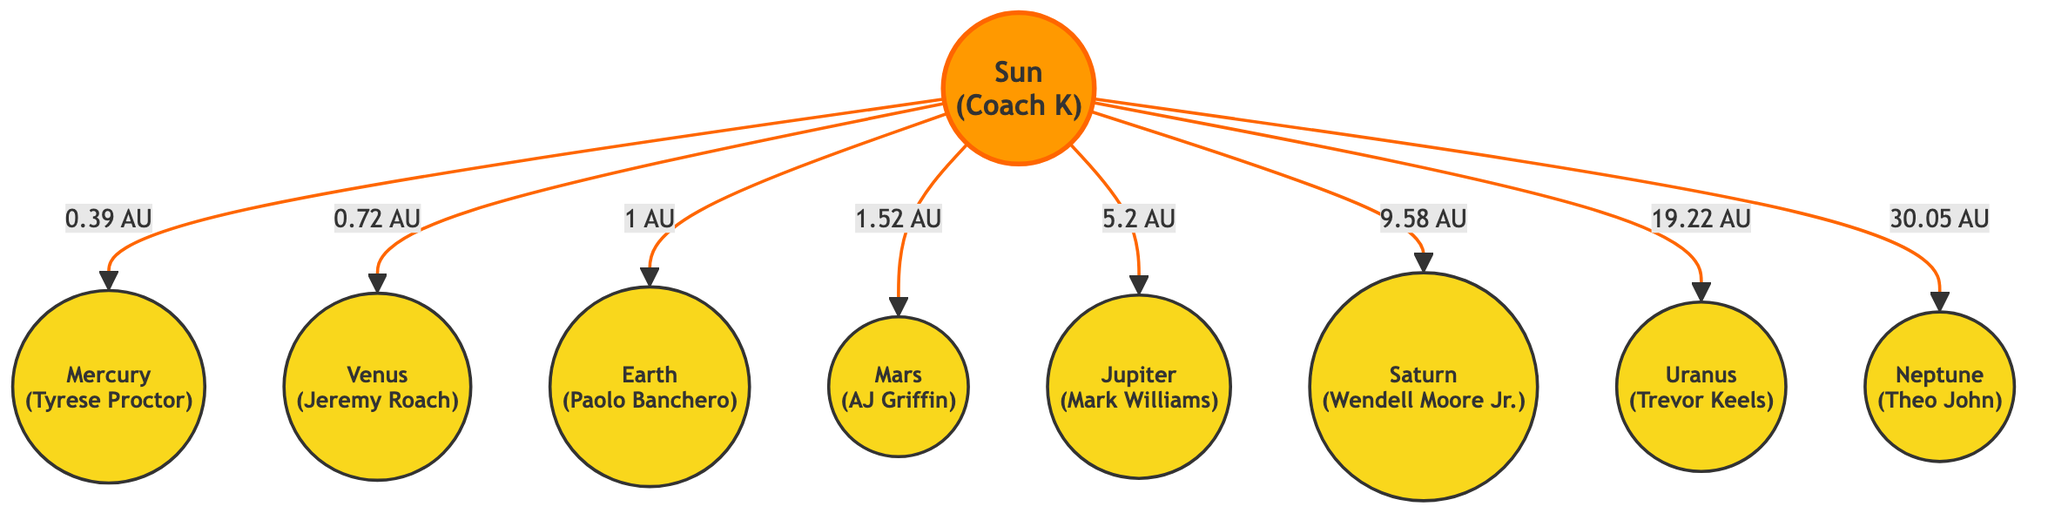What is the distance from the Sun to Mars? The Sun is connected to Mars by a link labeled "1.52 AU". This indicates that the distance from the Sun to Mars is 1.52 astronomical units.
Answer: 1.52 AU Who is represented by Jupiter? Jupiter is represented in the diagram by the label "Jupiter<br/>(Mark Williams)", which indicates that Mark Williams is the player associated with the planet Jupiter.
Answer: Mark Williams Which planet is closest to the Sun? Mercury is directly connected to the Sun with the shortest distance labeled "0.39 AU", making it the closest planet to the Sun.
Answer: Mercury How many planets are represented in this diagram? The diagram clearly shows eight planetary nodes connected to the Sun, which can be counted as each node is distinct and labeled. Thus, the total number of planets is eight.
Answer: Eight Which player corresponds to Neptune? The label next to Neptune reads "Neptune<br/>(Theo John)", indicating that Theo John represents the planet Neptune.
Answer: Theo John What is the distance from the Sun to Saturn? The link from the Sun to Saturn is labeled "9.58 AU", meaning the distance from the Sun to Saturn is 9.58 astronomical units.
Answer: 9.58 AU Which planet has the greatest distance from the Sun? Neptune is the farthest planet in this diagram, indicated by its distance of "30.05 AU" from the Sun, which is the largest value shown.
Answer: Neptune Is Uranus further from the Sun than Saturn? The distance from the Sun to Uranus is shown as "19.22 AU", and the distance to Saturn is "9.58 AU". Since 19.22 AU is greater than 9.58 AU, Uranus is indeed further from the Sun than Saturn.
Answer: Yes 